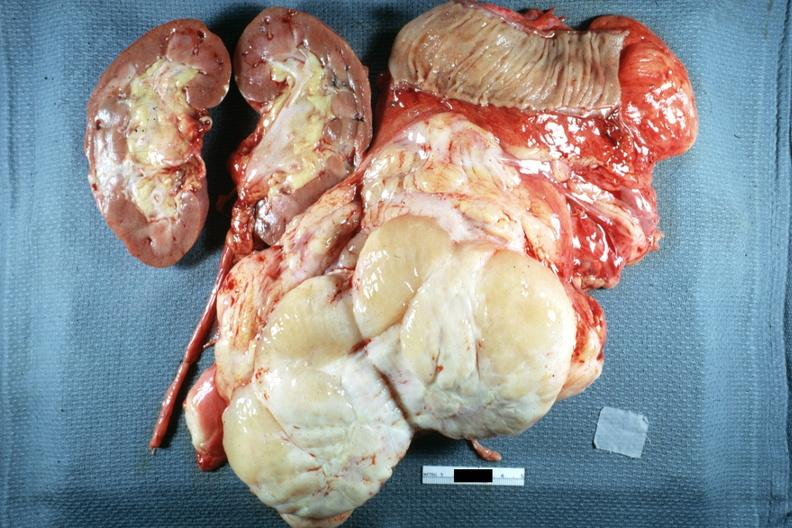where is this area in the body?
Answer the question using a single word or phrase. Abdomen 